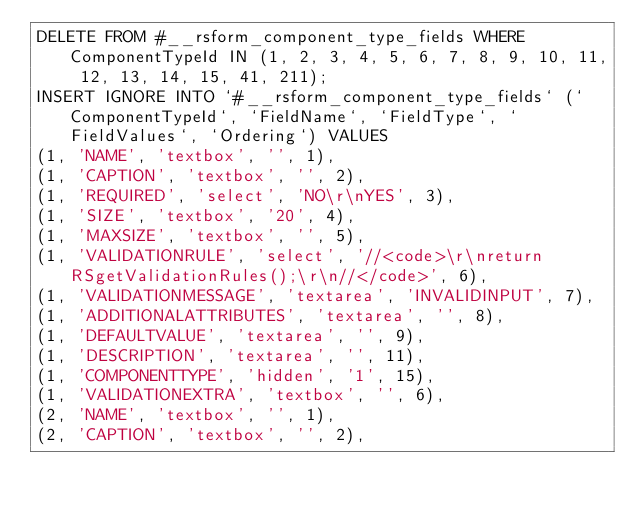<code> <loc_0><loc_0><loc_500><loc_500><_SQL_>DELETE FROM #__rsform_component_type_fields WHERE ComponentTypeId IN (1, 2, 3, 4, 5, 6, 7, 8, 9, 10, 11, 12, 13, 14, 15, 41, 211);
INSERT IGNORE INTO `#__rsform_component_type_fields` (`ComponentTypeId`, `FieldName`, `FieldType`, `FieldValues`, `Ordering`) VALUES
(1, 'NAME', 'textbox', '', 1),
(1, 'CAPTION', 'textbox', '', 2),
(1, 'REQUIRED', 'select', 'NO\r\nYES', 3),
(1, 'SIZE', 'textbox', '20', 4),
(1, 'MAXSIZE', 'textbox', '', 5),
(1, 'VALIDATIONRULE', 'select', '//<code>\r\nreturn RSgetValidationRules();\r\n//</code>', 6),
(1, 'VALIDATIONMESSAGE', 'textarea', 'INVALIDINPUT', 7),
(1, 'ADDITIONALATTRIBUTES', 'textarea', '', 8),
(1, 'DEFAULTVALUE', 'textarea', '', 9),
(1, 'DESCRIPTION', 'textarea', '', 11),
(1, 'COMPONENTTYPE', 'hidden', '1', 15),
(1, 'VALIDATIONEXTRA', 'textbox', '', 6),
(2, 'NAME', 'textbox', '', 1),
(2, 'CAPTION', 'textbox', '', 2),</code> 